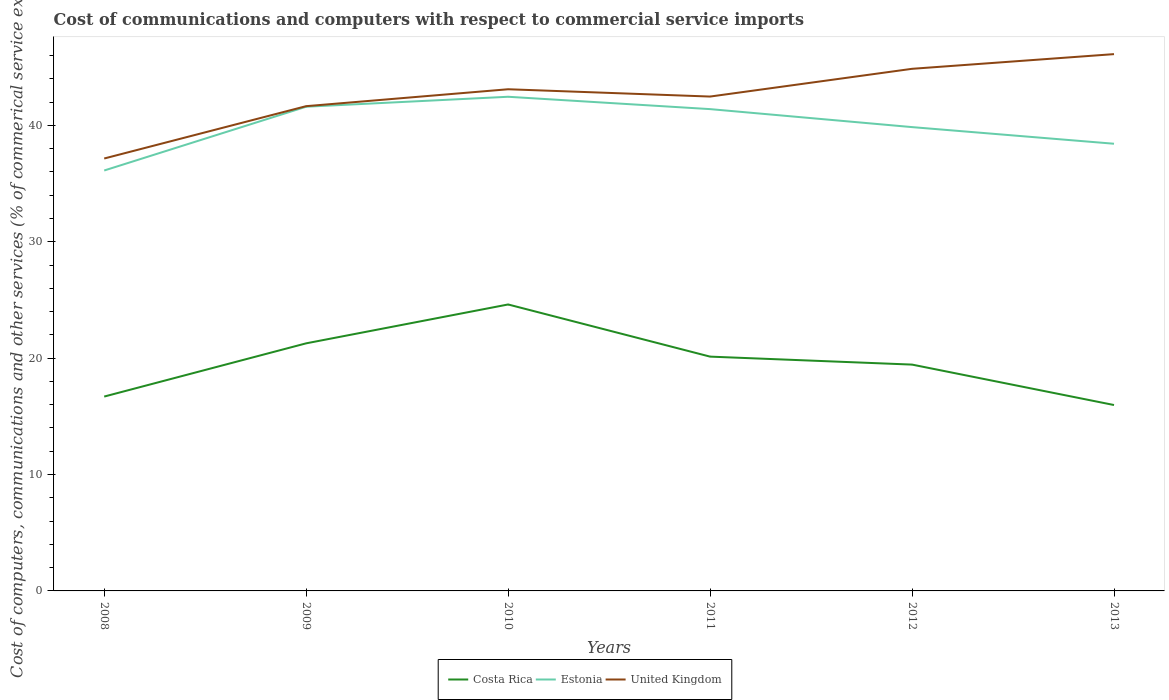How many different coloured lines are there?
Ensure brevity in your answer.  3. Is the number of lines equal to the number of legend labels?
Your response must be concise. Yes. Across all years, what is the maximum cost of communications and computers in Estonia?
Your response must be concise. 36.12. In which year was the cost of communications and computers in Costa Rica maximum?
Provide a succinct answer. 2013. What is the total cost of communications and computers in Estonia in the graph?
Provide a succinct answer. 1.55. What is the difference between the highest and the second highest cost of communications and computers in Estonia?
Keep it short and to the point. 6.34. What is the difference between the highest and the lowest cost of communications and computers in United Kingdom?
Give a very brief answer. 3. Is the cost of communications and computers in United Kingdom strictly greater than the cost of communications and computers in Costa Rica over the years?
Offer a very short reply. No. How many lines are there?
Provide a succinct answer. 3. Does the graph contain any zero values?
Offer a very short reply. No. Does the graph contain grids?
Your answer should be very brief. No. How many legend labels are there?
Give a very brief answer. 3. What is the title of the graph?
Ensure brevity in your answer.  Cost of communications and computers with respect to commercial service imports. What is the label or title of the Y-axis?
Provide a succinct answer. Cost of computers, communications and other services (% of commerical service exports). What is the Cost of computers, communications and other services (% of commerical service exports) in Costa Rica in 2008?
Your answer should be compact. 16.7. What is the Cost of computers, communications and other services (% of commerical service exports) in Estonia in 2008?
Make the answer very short. 36.12. What is the Cost of computers, communications and other services (% of commerical service exports) of United Kingdom in 2008?
Give a very brief answer. 37.16. What is the Cost of computers, communications and other services (% of commerical service exports) of Costa Rica in 2009?
Make the answer very short. 21.27. What is the Cost of computers, communications and other services (% of commerical service exports) in Estonia in 2009?
Offer a very short reply. 41.61. What is the Cost of computers, communications and other services (% of commerical service exports) in United Kingdom in 2009?
Provide a succinct answer. 41.65. What is the Cost of computers, communications and other services (% of commerical service exports) in Costa Rica in 2010?
Offer a very short reply. 24.61. What is the Cost of computers, communications and other services (% of commerical service exports) in Estonia in 2010?
Provide a short and direct response. 42.46. What is the Cost of computers, communications and other services (% of commerical service exports) of United Kingdom in 2010?
Your answer should be very brief. 43.11. What is the Cost of computers, communications and other services (% of commerical service exports) of Costa Rica in 2011?
Make the answer very short. 20.13. What is the Cost of computers, communications and other services (% of commerical service exports) in Estonia in 2011?
Make the answer very short. 41.4. What is the Cost of computers, communications and other services (% of commerical service exports) of United Kingdom in 2011?
Provide a short and direct response. 42.48. What is the Cost of computers, communications and other services (% of commerical service exports) in Costa Rica in 2012?
Keep it short and to the point. 19.45. What is the Cost of computers, communications and other services (% of commerical service exports) in Estonia in 2012?
Make the answer very short. 39.85. What is the Cost of computers, communications and other services (% of commerical service exports) of United Kingdom in 2012?
Provide a succinct answer. 44.86. What is the Cost of computers, communications and other services (% of commerical service exports) in Costa Rica in 2013?
Make the answer very short. 15.97. What is the Cost of computers, communications and other services (% of commerical service exports) in Estonia in 2013?
Your answer should be very brief. 38.42. What is the Cost of computers, communications and other services (% of commerical service exports) in United Kingdom in 2013?
Your answer should be very brief. 46.12. Across all years, what is the maximum Cost of computers, communications and other services (% of commerical service exports) of Costa Rica?
Provide a short and direct response. 24.61. Across all years, what is the maximum Cost of computers, communications and other services (% of commerical service exports) in Estonia?
Offer a very short reply. 42.46. Across all years, what is the maximum Cost of computers, communications and other services (% of commerical service exports) in United Kingdom?
Ensure brevity in your answer.  46.12. Across all years, what is the minimum Cost of computers, communications and other services (% of commerical service exports) of Costa Rica?
Your answer should be compact. 15.97. Across all years, what is the minimum Cost of computers, communications and other services (% of commerical service exports) of Estonia?
Give a very brief answer. 36.12. Across all years, what is the minimum Cost of computers, communications and other services (% of commerical service exports) of United Kingdom?
Give a very brief answer. 37.16. What is the total Cost of computers, communications and other services (% of commerical service exports) of Costa Rica in the graph?
Keep it short and to the point. 118.14. What is the total Cost of computers, communications and other services (% of commerical service exports) of Estonia in the graph?
Provide a succinct answer. 239.86. What is the total Cost of computers, communications and other services (% of commerical service exports) in United Kingdom in the graph?
Your answer should be compact. 255.38. What is the difference between the Cost of computers, communications and other services (% of commerical service exports) in Costa Rica in 2008 and that in 2009?
Keep it short and to the point. -4.57. What is the difference between the Cost of computers, communications and other services (% of commerical service exports) in Estonia in 2008 and that in 2009?
Offer a very short reply. -5.48. What is the difference between the Cost of computers, communications and other services (% of commerical service exports) in United Kingdom in 2008 and that in 2009?
Give a very brief answer. -4.5. What is the difference between the Cost of computers, communications and other services (% of commerical service exports) of Costa Rica in 2008 and that in 2010?
Provide a short and direct response. -7.91. What is the difference between the Cost of computers, communications and other services (% of commerical service exports) in Estonia in 2008 and that in 2010?
Ensure brevity in your answer.  -6.34. What is the difference between the Cost of computers, communications and other services (% of commerical service exports) in United Kingdom in 2008 and that in 2010?
Provide a short and direct response. -5.95. What is the difference between the Cost of computers, communications and other services (% of commerical service exports) of Costa Rica in 2008 and that in 2011?
Offer a very short reply. -3.43. What is the difference between the Cost of computers, communications and other services (% of commerical service exports) of Estonia in 2008 and that in 2011?
Provide a short and direct response. -5.27. What is the difference between the Cost of computers, communications and other services (% of commerical service exports) in United Kingdom in 2008 and that in 2011?
Keep it short and to the point. -5.32. What is the difference between the Cost of computers, communications and other services (% of commerical service exports) in Costa Rica in 2008 and that in 2012?
Your answer should be very brief. -2.75. What is the difference between the Cost of computers, communications and other services (% of commerical service exports) in Estonia in 2008 and that in 2012?
Provide a succinct answer. -3.73. What is the difference between the Cost of computers, communications and other services (% of commerical service exports) in United Kingdom in 2008 and that in 2012?
Offer a very short reply. -7.71. What is the difference between the Cost of computers, communications and other services (% of commerical service exports) of Costa Rica in 2008 and that in 2013?
Make the answer very short. 0.73. What is the difference between the Cost of computers, communications and other services (% of commerical service exports) in Estonia in 2008 and that in 2013?
Provide a succinct answer. -2.3. What is the difference between the Cost of computers, communications and other services (% of commerical service exports) in United Kingdom in 2008 and that in 2013?
Offer a very short reply. -8.97. What is the difference between the Cost of computers, communications and other services (% of commerical service exports) of Costa Rica in 2009 and that in 2010?
Your answer should be compact. -3.34. What is the difference between the Cost of computers, communications and other services (% of commerical service exports) in Estonia in 2009 and that in 2010?
Provide a succinct answer. -0.85. What is the difference between the Cost of computers, communications and other services (% of commerical service exports) in United Kingdom in 2009 and that in 2010?
Your response must be concise. -1.45. What is the difference between the Cost of computers, communications and other services (% of commerical service exports) in Costa Rica in 2009 and that in 2011?
Keep it short and to the point. 1.14. What is the difference between the Cost of computers, communications and other services (% of commerical service exports) in Estonia in 2009 and that in 2011?
Your answer should be very brief. 0.21. What is the difference between the Cost of computers, communications and other services (% of commerical service exports) of United Kingdom in 2009 and that in 2011?
Your response must be concise. -0.83. What is the difference between the Cost of computers, communications and other services (% of commerical service exports) in Costa Rica in 2009 and that in 2012?
Provide a short and direct response. 1.83. What is the difference between the Cost of computers, communications and other services (% of commerical service exports) of Estonia in 2009 and that in 2012?
Offer a terse response. 1.75. What is the difference between the Cost of computers, communications and other services (% of commerical service exports) of United Kingdom in 2009 and that in 2012?
Make the answer very short. -3.21. What is the difference between the Cost of computers, communications and other services (% of commerical service exports) in Costa Rica in 2009 and that in 2013?
Provide a succinct answer. 5.3. What is the difference between the Cost of computers, communications and other services (% of commerical service exports) in Estonia in 2009 and that in 2013?
Provide a succinct answer. 3.18. What is the difference between the Cost of computers, communications and other services (% of commerical service exports) in United Kingdom in 2009 and that in 2013?
Provide a succinct answer. -4.47. What is the difference between the Cost of computers, communications and other services (% of commerical service exports) in Costa Rica in 2010 and that in 2011?
Your response must be concise. 4.48. What is the difference between the Cost of computers, communications and other services (% of commerical service exports) of Estonia in 2010 and that in 2011?
Give a very brief answer. 1.06. What is the difference between the Cost of computers, communications and other services (% of commerical service exports) in United Kingdom in 2010 and that in 2011?
Make the answer very short. 0.63. What is the difference between the Cost of computers, communications and other services (% of commerical service exports) in Costa Rica in 2010 and that in 2012?
Make the answer very short. 5.17. What is the difference between the Cost of computers, communications and other services (% of commerical service exports) of Estonia in 2010 and that in 2012?
Your response must be concise. 2.61. What is the difference between the Cost of computers, communications and other services (% of commerical service exports) of United Kingdom in 2010 and that in 2012?
Your response must be concise. -1.76. What is the difference between the Cost of computers, communications and other services (% of commerical service exports) in Costa Rica in 2010 and that in 2013?
Keep it short and to the point. 8.64. What is the difference between the Cost of computers, communications and other services (% of commerical service exports) in Estonia in 2010 and that in 2013?
Provide a short and direct response. 4.04. What is the difference between the Cost of computers, communications and other services (% of commerical service exports) in United Kingdom in 2010 and that in 2013?
Your answer should be very brief. -3.02. What is the difference between the Cost of computers, communications and other services (% of commerical service exports) of Costa Rica in 2011 and that in 2012?
Your answer should be very brief. 0.68. What is the difference between the Cost of computers, communications and other services (% of commerical service exports) in Estonia in 2011 and that in 2012?
Your response must be concise. 1.55. What is the difference between the Cost of computers, communications and other services (% of commerical service exports) in United Kingdom in 2011 and that in 2012?
Provide a succinct answer. -2.38. What is the difference between the Cost of computers, communications and other services (% of commerical service exports) in Costa Rica in 2011 and that in 2013?
Provide a succinct answer. 4.16. What is the difference between the Cost of computers, communications and other services (% of commerical service exports) in Estonia in 2011 and that in 2013?
Your response must be concise. 2.98. What is the difference between the Cost of computers, communications and other services (% of commerical service exports) of United Kingdom in 2011 and that in 2013?
Make the answer very short. -3.65. What is the difference between the Cost of computers, communications and other services (% of commerical service exports) in Costa Rica in 2012 and that in 2013?
Your answer should be very brief. 3.47. What is the difference between the Cost of computers, communications and other services (% of commerical service exports) in Estonia in 2012 and that in 2013?
Provide a short and direct response. 1.43. What is the difference between the Cost of computers, communications and other services (% of commerical service exports) in United Kingdom in 2012 and that in 2013?
Give a very brief answer. -1.26. What is the difference between the Cost of computers, communications and other services (% of commerical service exports) in Costa Rica in 2008 and the Cost of computers, communications and other services (% of commerical service exports) in Estonia in 2009?
Keep it short and to the point. -24.9. What is the difference between the Cost of computers, communications and other services (% of commerical service exports) in Costa Rica in 2008 and the Cost of computers, communications and other services (% of commerical service exports) in United Kingdom in 2009?
Provide a short and direct response. -24.95. What is the difference between the Cost of computers, communications and other services (% of commerical service exports) of Estonia in 2008 and the Cost of computers, communications and other services (% of commerical service exports) of United Kingdom in 2009?
Ensure brevity in your answer.  -5.53. What is the difference between the Cost of computers, communications and other services (% of commerical service exports) of Costa Rica in 2008 and the Cost of computers, communications and other services (% of commerical service exports) of Estonia in 2010?
Your answer should be very brief. -25.76. What is the difference between the Cost of computers, communications and other services (% of commerical service exports) in Costa Rica in 2008 and the Cost of computers, communications and other services (% of commerical service exports) in United Kingdom in 2010?
Offer a terse response. -26.41. What is the difference between the Cost of computers, communications and other services (% of commerical service exports) in Estonia in 2008 and the Cost of computers, communications and other services (% of commerical service exports) in United Kingdom in 2010?
Make the answer very short. -6.98. What is the difference between the Cost of computers, communications and other services (% of commerical service exports) of Costa Rica in 2008 and the Cost of computers, communications and other services (% of commerical service exports) of Estonia in 2011?
Provide a succinct answer. -24.7. What is the difference between the Cost of computers, communications and other services (% of commerical service exports) in Costa Rica in 2008 and the Cost of computers, communications and other services (% of commerical service exports) in United Kingdom in 2011?
Your response must be concise. -25.78. What is the difference between the Cost of computers, communications and other services (% of commerical service exports) in Estonia in 2008 and the Cost of computers, communications and other services (% of commerical service exports) in United Kingdom in 2011?
Your response must be concise. -6.35. What is the difference between the Cost of computers, communications and other services (% of commerical service exports) in Costa Rica in 2008 and the Cost of computers, communications and other services (% of commerical service exports) in Estonia in 2012?
Offer a terse response. -23.15. What is the difference between the Cost of computers, communications and other services (% of commerical service exports) of Costa Rica in 2008 and the Cost of computers, communications and other services (% of commerical service exports) of United Kingdom in 2012?
Provide a succinct answer. -28.16. What is the difference between the Cost of computers, communications and other services (% of commerical service exports) in Estonia in 2008 and the Cost of computers, communications and other services (% of commerical service exports) in United Kingdom in 2012?
Make the answer very short. -8.74. What is the difference between the Cost of computers, communications and other services (% of commerical service exports) in Costa Rica in 2008 and the Cost of computers, communications and other services (% of commerical service exports) in Estonia in 2013?
Your response must be concise. -21.72. What is the difference between the Cost of computers, communications and other services (% of commerical service exports) of Costa Rica in 2008 and the Cost of computers, communications and other services (% of commerical service exports) of United Kingdom in 2013?
Offer a terse response. -29.42. What is the difference between the Cost of computers, communications and other services (% of commerical service exports) in Estonia in 2008 and the Cost of computers, communications and other services (% of commerical service exports) in United Kingdom in 2013?
Give a very brief answer. -10. What is the difference between the Cost of computers, communications and other services (% of commerical service exports) of Costa Rica in 2009 and the Cost of computers, communications and other services (% of commerical service exports) of Estonia in 2010?
Offer a terse response. -21.19. What is the difference between the Cost of computers, communications and other services (% of commerical service exports) in Costa Rica in 2009 and the Cost of computers, communications and other services (% of commerical service exports) in United Kingdom in 2010?
Provide a short and direct response. -21.83. What is the difference between the Cost of computers, communications and other services (% of commerical service exports) of Estonia in 2009 and the Cost of computers, communications and other services (% of commerical service exports) of United Kingdom in 2010?
Keep it short and to the point. -1.5. What is the difference between the Cost of computers, communications and other services (% of commerical service exports) of Costa Rica in 2009 and the Cost of computers, communications and other services (% of commerical service exports) of Estonia in 2011?
Your response must be concise. -20.13. What is the difference between the Cost of computers, communications and other services (% of commerical service exports) of Costa Rica in 2009 and the Cost of computers, communications and other services (% of commerical service exports) of United Kingdom in 2011?
Provide a short and direct response. -21.2. What is the difference between the Cost of computers, communications and other services (% of commerical service exports) in Estonia in 2009 and the Cost of computers, communications and other services (% of commerical service exports) in United Kingdom in 2011?
Your answer should be compact. -0.87. What is the difference between the Cost of computers, communications and other services (% of commerical service exports) in Costa Rica in 2009 and the Cost of computers, communications and other services (% of commerical service exports) in Estonia in 2012?
Your answer should be very brief. -18.58. What is the difference between the Cost of computers, communications and other services (% of commerical service exports) of Costa Rica in 2009 and the Cost of computers, communications and other services (% of commerical service exports) of United Kingdom in 2012?
Offer a terse response. -23.59. What is the difference between the Cost of computers, communications and other services (% of commerical service exports) of Estonia in 2009 and the Cost of computers, communications and other services (% of commerical service exports) of United Kingdom in 2012?
Provide a succinct answer. -3.26. What is the difference between the Cost of computers, communications and other services (% of commerical service exports) of Costa Rica in 2009 and the Cost of computers, communications and other services (% of commerical service exports) of Estonia in 2013?
Provide a short and direct response. -17.15. What is the difference between the Cost of computers, communications and other services (% of commerical service exports) in Costa Rica in 2009 and the Cost of computers, communications and other services (% of commerical service exports) in United Kingdom in 2013?
Ensure brevity in your answer.  -24.85. What is the difference between the Cost of computers, communications and other services (% of commerical service exports) in Estonia in 2009 and the Cost of computers, communications and other services (% of commerical service exports) in United Kingdom in 2013?
Make the answer very short. -4.52. What is the difference between the Cost of computers, communications and other services (% of commerical service exports) in Costa Rica in 2010 and the Cost of computers, communications and other services (% of commerical service exports) in Estonia in 2011?
Offer a terse response. -16.79. What is the difference between the Cost of computers, communications and other services (% of commerical service exports) of Costa Rica in 2010 and the Cost of computers, communications and other services (% of commerical service exports) of United Kingdom in 2011?
Your response must be concise. -17.87. What is the difference between the Cost of computers, communications and other services (% of commerical service exports) in Estonia in 2010 and the Cost of computers, communications and other services (% of commerical service exports) in United Kingdom in 2011?
Your response must be concise. -0.02. What is the difference between the Cost of computers, communications and other services (% of commerical service exports) of Costa Rica in 2010 and the Cost of computers, communications and other services (% of commerical service exports) of Estonia in 2012?
Provide a succinct answer. -15.24. What is the difference between the Cost of computers, communications and other services (% of commerical service exports) in Costa Rica in 2010 and the Cost of computers, communications and other services (% of commerical service exports) in United Kingdom in 2012?
Ensure brevity in your answer.  -20.25. What is the difference between the Cost of computers, communications and other services (% of commerical service exports) of Estonia in 2010 and the Cost of computers, communications and other services (% of commerical service exports) of United Kingdom in 2012?
Give a very brief answer. -2.4. What is the difference between the Cost of computers, communications and other services (% of commerical service exports) of Costa Rica in 2010 and the Cost of computers, communications and other services (% of commerical service exports) of Estonia in 2013?
Make the answer very short. -13.81. What is the difference between the Cost of computers, communications and other services (% of commerical service exports) in Costa Rica in 2010 and the Cost of computers, communications and other services (% of commerical service exports) in United Kingdom in 2013?
Give a very brief answer. -21.51. What is the difference between the Cost of computers, communications and other services (% of commerical service exports) in Estonia in 2010 and the Cost of computers, communications and other services (% of commerical service exports) in United Kingdom in 2013?
Keep it short and to the point. -3.66. What is the difference between the Cost of computers, communications and other services (% of commerical service exports) of Costa Rica in 2011 and the Cost of computers, communications and other services (% of commerical service exports) of Estonia in 2012?
Make the answer very short. -19.72. What is the difference between the Cost of computers, communications and other services (% of commerical service exports) of Costa Rica in 2011 and the Cost of computers, communications and other services (% of commerical service exports) of United Kingdom in 2012?
Your answer should be compact. -24.73. What is the difference between the Cost of computers, communications and other services (% of commerical service exports) in Estonia in 2011 and the Cost of computers, communications and other services (% of commerical service exports) in United Kingdom in 2012?
Make the answer very short. -3.46. What is the difference between the Cost of computers, communications and other services (% of commerical service exports) of Costa Rica in 2011 and the Cost of computers, communications and other services (% of commerical service exports) of Estonia in 2013?
Your response must be concise. -18.29. What is the difference between the Cost of computers, communications and other services (% of commerical service exports) of Costa Rica in 2011 and the Cost of computers, communications and other services (% of commerical service exports) of United Kingdom in 2013?
Your answer should be very brief. -25.99. What is the difference between the Cost of computers, communications and other services (% of commerical service exports) in Estonia in 2011 and the Cost of computers, communications and other services (% of commerical service exports) in United Kingdom in 2013?
Your response must be concise. -4.73. What is the difference between the Cost of computers, communications and other services (% of commerical service exports) in Costa Rica in 2012 and the Cost of computers, communications and other services (% of commerical service exports) in Estonia in 2013?
Provide a short and direct response. -18.98. What is the difference between the Cost of computers, communications and other services (% of commerical service exports) of Costa Rica in 2012 and the Cost of computers, communications and other services (% of commerical service exports) of United Kingdom in 2013?
Your answer should be very brief. -26.68. What is the difference between the Cost of computers, communications and other services (% of commerical service exports) of Estonia in 2012 and the Cost of computers, communications and other services (% of commerical service exports) of United Kingdom in 2013?
Make the answer very short. -6.27. What is the average Cost of computers, communications and other services (% of commerical service exports) of Costa Rica per year?
Ensure brevity in your answer.  19.69. What is the average Cost of computers, communications and other services (% of commerical service exports) in Estonia per year?
Ensure brevity in your answer.  39.98. What is the average Cost of computers, communications and other services (% of commerical service exports) of United Kingdom per year?
Your answer should be compact. 42.56. In the year 2008, what is the difference between the Cost of computers, communications and other services (% of commerical service exports) in Costa Rica and Cost of computers, communications and other services (% of commerical service exports) in Estonia?
Your answer should be very brief. -19.42. In the year 2008, what is the difference between the Cost of computers, communications and other services (% of commerical service exports) of Costa Rica and Cost of computers, communications and other services (% of commerical service exports) of United Kingdom?
Ensure brevity in your answer.  -20.46. In the year 2008, what is the difference between the Cost of computers, communications and other services (% of commerical service exports) in Estonia and Cost of computers, communications and other services (% of commerical service exports) in United Kingdom?
Make the answer very short. -1.03. In the year 2009, what is the difference between the Cost of computers, communications and other services (% of commerical service exports) of Costa Rica and Cost of computers, communications and other services (% of commerical service exports) of Estonia?
Give a very brief answer. -20.33. In the year 2009, what is the difference between the Cost of computers, communications and other services (% of commerical service exports) in Costa Rica and Cost of computers, communications and other services (% of commerical service exports) in United Kingdom?
Your response must be concise. -20.38. In the year 2009, what is the difference between the Cost of computers, communications and other services (% of commerical service exports) of Estonia and Cost of computers, communications and other services (% of commerical service exports) of United Kingdom?
Provide a short and direct response. -0.05. In the year 2010, what is the difference between the Cost of computers, communications and other services (% of commerical service exports) in Costa Rica and Cost of computers, communications and other services (% of commerical service exports) in Estonia?
Offer a very short reply. -17.85. In the year 2010, what is the difference between the Cost of computers, communications and other services (% of commerical service exports) in Costa Rica and Cost of computers, communications and other services (% of commerical service exports) in United Kingdom?
Give a very brief answer. -18.49. In the year 2010, what is the difference between the Cost of computers, communications and other services (% of commerical service exports) of Estonia and Cost of computers, communications and other services (% of commerical service exports) of United Kingdom?
Provide a succinct answer. -0.65. In the year 2011, what is the difference between the Cost of computers, communications and other services (% of commerical service exports) in Costa Rica and Cost of computers, communications and other services (% of commerical service exports) in Estonia?
Offer a terse response. -21.27. In the year 2011, what is the difference between the Cost of computers, communications and other services (% of commerical service exports) of Costa Rica and Cost of computers, communications and other services (% of commerical service exports) of United Kingdom?
Provide a short and direct response. -22.35. In the year 2011, what is the difference between the Cost of computers, communications and other services (% of commerical service exports) in Estonia and Cost of computers, communications and other services (% of commerical service exports) in United Kingdom?
Your answer should be very brief. -1.08. In the year 2012, what is the difference between the Cost of computers, communications and other services (% of commerical service exports) in Costa Rica and Cost of computers, communications and other services (% of commerical service exports) in Estonia?
Offer a terse response. -20.41. In the year 2012, what is the difference between the Cost of computers, communications and other services (% of commerical service exports) in Costa Rica and Cost of computers, communications and other services (% of commerical service exports) in United Kingdom?
Give a very brief answer. -25.41. In the year 2012, what is the difference between the Cost of computers, communications and other services (% of commerical service exports) of Estonia and Cost of computers, communications and other services (% of commerical service exports) of United Kingdom?
Offer a very short reply. -5.01. In the year 2013, what is the difference between the Cost of computers, communications and other services (% of commerical service exports) of Costa Rica and Cost of computers, communications and other services (% of commerical service exports) of Estonia?
Your answer should be very brief. -22.45. In the year 2013, what is the difference between the Cost of computers, communications and other services (% of commerical service exports) of Costa Rica and Cost of computers, communications and other services (% of commerical service exports) of United Kingdom?
Make the answer very short. -30.15. In the year 2013, what is the difference between the Cost of computers, communications and other services (% of commerical service exports) of Estonia and Cost of computers, communications and other services (% of commerical service exports) of United Kingdom?
Your answer should be very brief. -7.7. What is the ratio of the Cost of computers, communications and other services (% of commerical service exports) in Costa Rica in 2008 to that in 2009?
Offer a very short reply. 0.79. What is the ratio of the Cost of computers, communications and other services (% of commerical service exports) of Estonia in 2008 to that in 2009?
Offer a terse response. 0.87. What is the ratio of the Cost of computers, communications and other services (% of commerical service exports) in United Kingdom in 2008 to that in 2009?
Ensure brevity in your answer.  0.89. What is the ratio of the Cost of computers, communications and other services (% of commerical service exports) in Costa Rica in 2008 to that in 2010?
Your answer should be very brief. 0.68. What is the ratio of the Cost of computers, communications and other services (% of commerical service exports) of Estonia in 2008 to that in 2010?
Provide a succinct answer. 0.85. What is the ratio of the Cost of computers, communications and other services (% of commerical service exports) of United Kingdom in 2008 to that in 2010?
Offer a terse response. 0.86. What is the ratio of the Cost of computers, communications and other services (% of commerical service exports) in Costa Rica in 2008 to that in 2011?
Ensure brevity in your answer.  0.83. What is the ratio of the Cost of computers, communications and other services (% of commerical service exports) of Estonia in 2008 to that in 2011?
Your answer should be compact. 0.87. What is the ratio of the Cost of computers, communications and other services (% of commerical service exports) of United Kingdom in 2008 to that in 2011?
Offer a terse response. 0.87. What is the ratio of the Cost of computers, communications and other services (% of commerical service exports) of Costa Rica in 2008 to that in 2012?
Give a very brief answer. 0.86. What is the ratio of the Cost of computers, communications and other services (% of commerical service exports) of Estonia in 2008 to that in 2012?
Your answer should be compact. 0.91. What is the ratio of the Cost of computers, communications and other services (% of commerical service exports) of United Kingdom in 2008 to that in 2012?
Make the answer very short. 0.83. What is the ratio of the Cost of computers, communications and other services (% of commerical service exports) of Costa Rica in 2008 to that in 2013?
Give a very brief answer. 1.05. What is the ratio of the Cost of computers, communications and other services (% of commerical service exports) of Estonia in 2008 to that in 2013?
Provide a succinct answer. 0.94. What is the ratio of the Cost of computers, communications and other services (% of commerical service exports) of United Kingdom in 2008 to that in 2013?
Provide a succinct answer. 0.81. What is the ratio of the Cost of computers, communications and other services (% of commerical service exports) of Costa Rica in 2009 to that in 2010?
Your answer should be very brief. 0.86. What is the ratio of the Cost of computers, communications and other services (% of commerical service exports) of Estonia in 2009 to that in 2010?
Ensure brevity in your answer.  0.98. What is the ratio of the Cost of computers, communications and other services (% of commerical service exports) in United Kingdom in 2009 to that in 2010?
Give a very brief answer. 0.97. What is the ratio of the Cost of computers, communications and other services (% of commerical service exports) in Costa Rica in 2009 to that in 2011?
Provide a short and direct response. 1.06. What is the ratio of the Cost of computers, communications and other services (% of commerical service exports) of Estonia in 2009 to that in 2011?
Offer a very short reply. 1. What is the ratio of the Cost of computers, communications and other services (% of commerical service exports) of United Kingdom in 2009 to that in 2011?
Your response must be concise. 0.98. What is the ratio of the Cost of computers, communications and other services (% of commerical service exports) of Costa Rica in 2009 to that in 2012?
Give a very brief answer. 1.09. What is the ratio of the Cost of computers, communications and other services (% of commerical service exports) of Estonia in 2009 to that in 2012?
Your answer should be very brief. 1.04. What is the ratio of the Cost of computers, communications and other services (% of commerical service exports) in United Kingdom in 2009 to that in 2012?
Provide a succinct answer. 0.93. What is the ratio of the Cost of computers, communications and other services (% of commerical service exports) in Costa Rica in 2009 to that in 2013?
Provide a succinct answer. 1.33. What is the ratio of the Cost of computers, communications and other services (% of commerical service exports) in Estonia in 2009 to that in 2013?
Your answer should be very brief. 1.08. What is the ratio of the Cost of computers, communications and other services (% of commerical service exports) in United Kingdom in 2009 to that in 2013?
Your answer should be compact. 0.9. What is the ratio of the Cost of computers, communications and other services (% of commerical service exports) in Costa Rica in 2010 to that in 2011?
Keep it short and to the point. 1.22. What is the ratio of the Cost of computers, communications and other services (% of commerical service exports) of Estonia in 2010 to that in 2011?
Your response must be concise. 1.03. What is the ratio of the Cost of computers, communications and other services (% of commerical service exports) in United Kingdom in 2010 to that in 2011?
Provide a short and direct response. 1.01. What is the ratio of the Cost of computers, communications and other services (% of commerical service exports) in Costa Rica in 2010 to that in 2012?
Offer a very short reply. 1.27. What is the ratio of the Cost of computers, communications and other services (% of commerical service exports) in Estonia in 2010 to that in 2012?
Your answer should be compact. 1.07. What is the ratio of the Cost of computers, communications and other services (% of commerical service exports) in United Kingdom in 2010 to that in 2012?
Make the answer very short. 0.96. What is the ratio of the Cost of computers, communications and other services (% of commerical service exports) of Costa Rica in 2010 to that in 2013?
Your answer should be very brief. 1.54. What is the ratio of the Cost of computers, communications and other services (% of commerical service exports) in Estonia in 2010 to that in 2013?
Provide a succinct answer. 1.11. What is the ratio of the Cost of computers, communications and other services (% of commerical service exports) in United Kingdom in 2010 to that in 2013?
Your answer should be very brief. 0.93. What is the ratio of the Cost of computers, communications and other services (% of commerical service exports) in Costa Rica in 2011 to that in 2012?
Your answer should be compact. 1.04. What is the ratio of the Cost of computers, communications and other services (% of commerical service exports) in Estonia in 2011 to that in 2012?
Ensure brevity in your answer.  1.04. What is the ratio of the Cost of computers, communications and other services (% of commerical service exports) of United Kingdom in 2011 to that in 2012?
Provide a short and direct response. 0.95. What is the ratio of the Cost of computers, communications and other services (% of commerical service exports) of Costa Rica in 2011 to that in 2013?
Ensure brevity in your answer.  1.26. What is the ratio of the Cost of computers, communications and other services (% of commerical service exports) in Estonia in 2011 to that in 2013?
Ensure brevity in your answer.  1.08. What is the ratio of the Cost of computers, communications and other services (% of commerical service exports) of United Kingdom in 2011 to that in 2013?
Ensure brevity in your answer.  0.92. What is the ratio of the Cost of computers, communications and other services (% of commerical service exports) in Costa Rica in 2012 to that in 2013?
Your response must be concise. 1.22. What is the ratio of the Cost of computers, communications and other services (% of commerical service exports) in Estonia in 2012 to that in 2013?
Your answer should be compact. 1.04. What is the ratio of the Cost of computers, communications and other services (% of commerical service exports) in United Kingdom in 2012 to that in 2013?
Offer a terse response. 0.97. What is the difference between the highest and the second highest Cost of computers, communications and other services (% of commerical service exports) in Costa Rica?
Make the answer very short. 3.34. What is the difference between the highest and the second highest Cost of computers, communications and other services (% of commerical service exports) in Estonia?
Make the answer very short. 0.85. What is the difference between the highest and the second highest Cost of computers, communications and other services (% of commerical service exports) of United Kingdom?
Your answer should be very brief. 1.26. What is the difference between the highest and the lowest Cost of computers, communications and other services (% of commerical service exports) in Costa Rica?
Give a very brief answer. 8.64. What is the difference between the highest and the lowest Cost of computers, communications and other services (% of commerical service exports) of Estonia?
Provide a short and direct response. 6.34. What is the difference between the highest and the lowest Cost of computers, communications and other services (% of commerical service exports) in United Kingdom?
Offer a terse response. 8.97. 